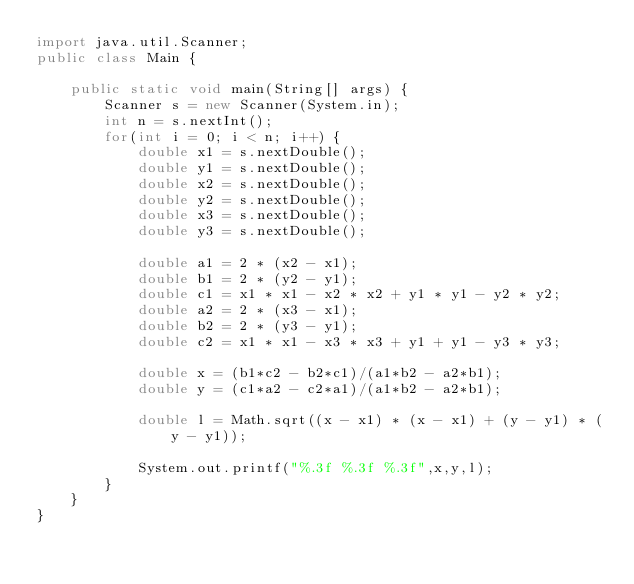<code> <loc_0><loc_0><loc_500><loc_500><_Java_>import java.util.Scanner;
public class Main {

	public static void main(String[] args) {
		Scanner s = new Scanner(System.in);
		int n = s.nextInt();
		for(int i = 0; i < n; i++) {
			double x1 = s.nextDouble();
			double y1 = s.nextDouble();
			double x2 = s.nextDouble();
			double y2 = s.nextDouble();
			double x3 = s.nextDouble();
			double y3 = s.nextDouble();
			
			double a1 = 2 * (x2 - x1);
			double b1 = 2 * (y2 - y1);
			double c1 = x1 * x1 - x2 * x2 + y1 * y1 - y2 * y2;
			double a2 = 2 * (x3 - x1);
			double b2 = 2 * (y3 - y1);
			double c2 = x1 * x1 - x3 * x3 + y1 + y1 - y3 * y3;
			
			double x = (b1*c2 - b2*c1)/(a1*b2 - a2*b1);
			double y = (c1*a2 - c2*a1)/(a1*b2 - a2*b1);
			
			double l = Math.sqrt((x - x1) * (x - x1) + (y - y1) * (y - y1));
			
			System.out.printf("%.3f %.3f %.3f",x,y,l);
		}
	}
}</code> 